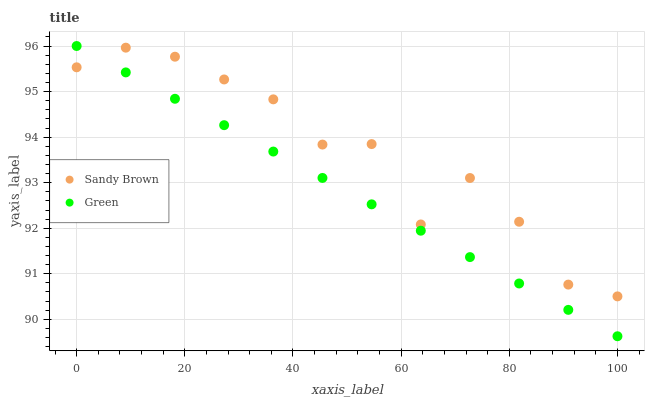Does Green have the minimum area under the curve?
Answer yes or no. Yes. Does Sandy Brown have the maximum area under the curve?
Answer yes or no. Yes. Does Sandy Brown have the minimum area under the curve?
Answer yes or no. No. Is Green the smoothest?
Answer yes or no. Yes. Is Sandy Brown the roughest?
Answer yes or no. Yes. Is Sandy Brown the smoothest?
Answer yes or no. No. Does Green have the lowest value?
Answer yes or no. Yes. Does Sandy Brown have the lowest value?
Answer yes or no. No. Does Green have the highest value?
Answer yes or no. Yes. Does Sandy Brown have the highest value?
Answer yes or no. No. Does Green intersect Sandy Brown?
Answer yes or no. Yes. Is Green less than Sandy Brown?
Answer yes or no. No. Is Green greater than Sandy Brown?
Answer yes or no. No. 